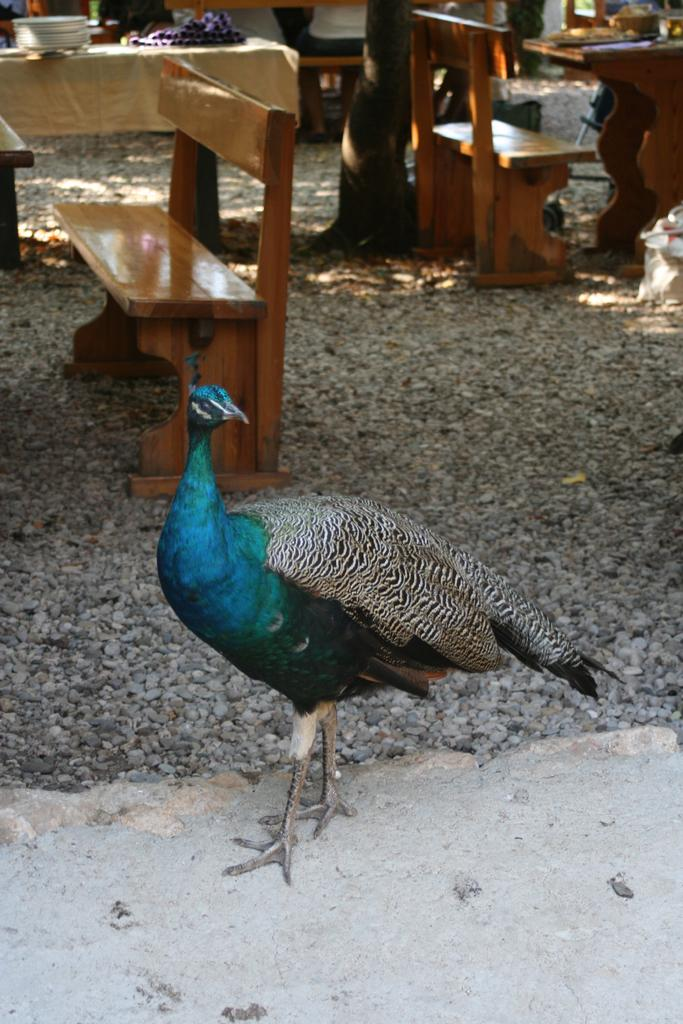What type of bird is in the image? There is a peacock in the image. Where is the peacock located in relation to other objects in the image? The peacock is near a bench. What other piece of furniture is present in the image? There is a table in the image. What is on the table in the image? There is a plate in the image. What can be seen in the background of the image? There is a tree in the background of the image. What is the income of the baby in the image? There is no baby present in the image, and therefore no information about their income can be provided. 